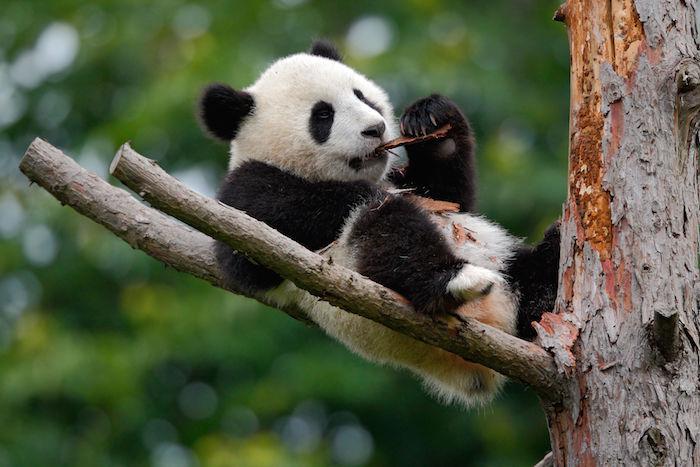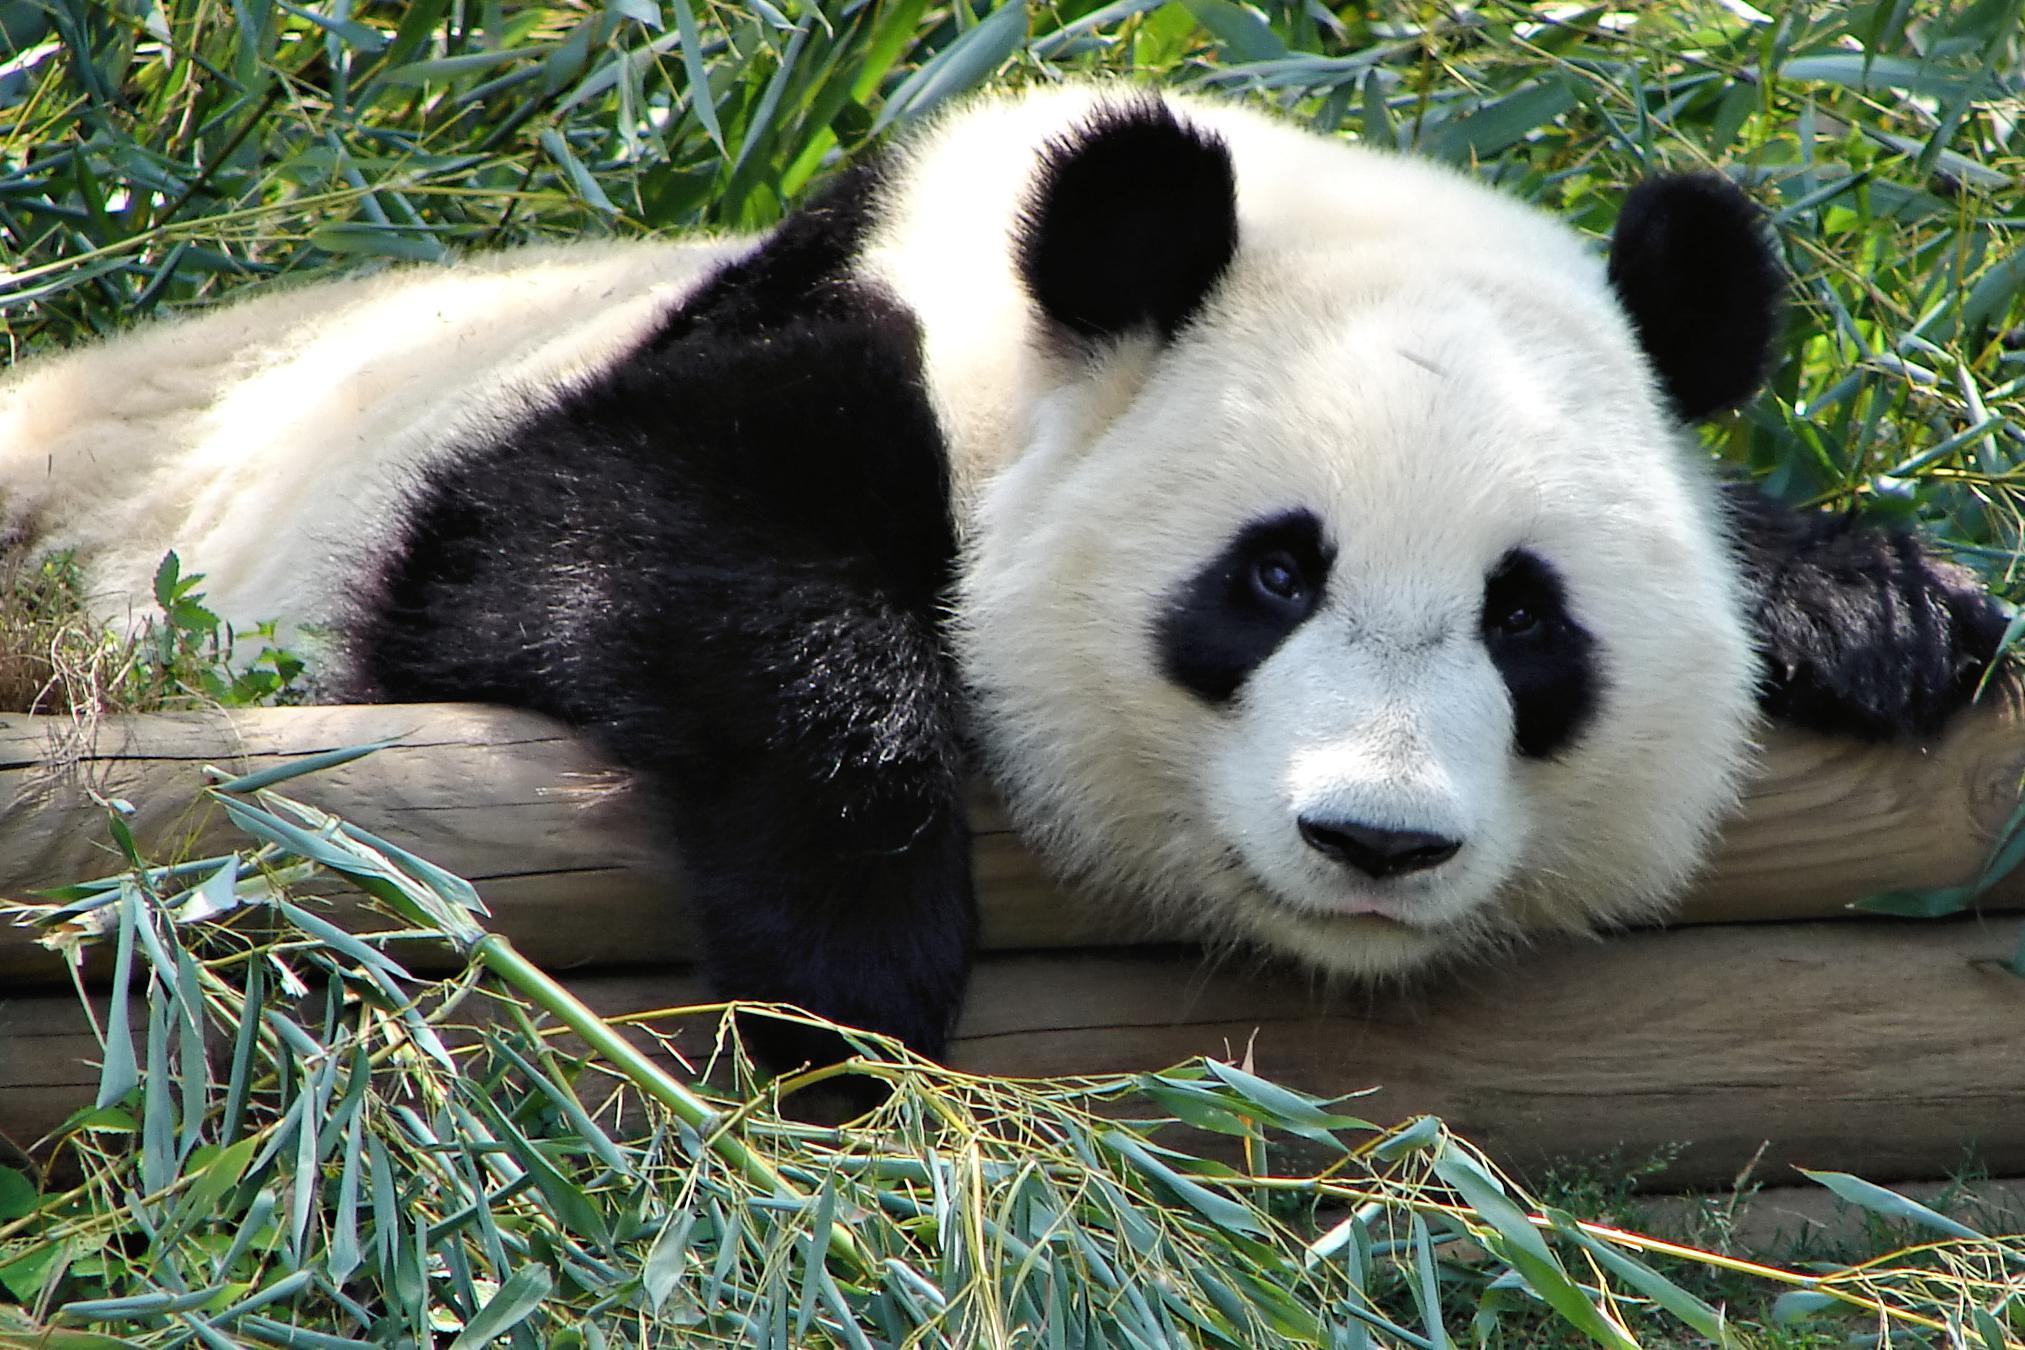The first image is the image on the left, the second image is the image on the right. For the images displayed, is the sentence "The panda on the left image is on a tree branch." factually correct? Answer yes or no. Yes. 